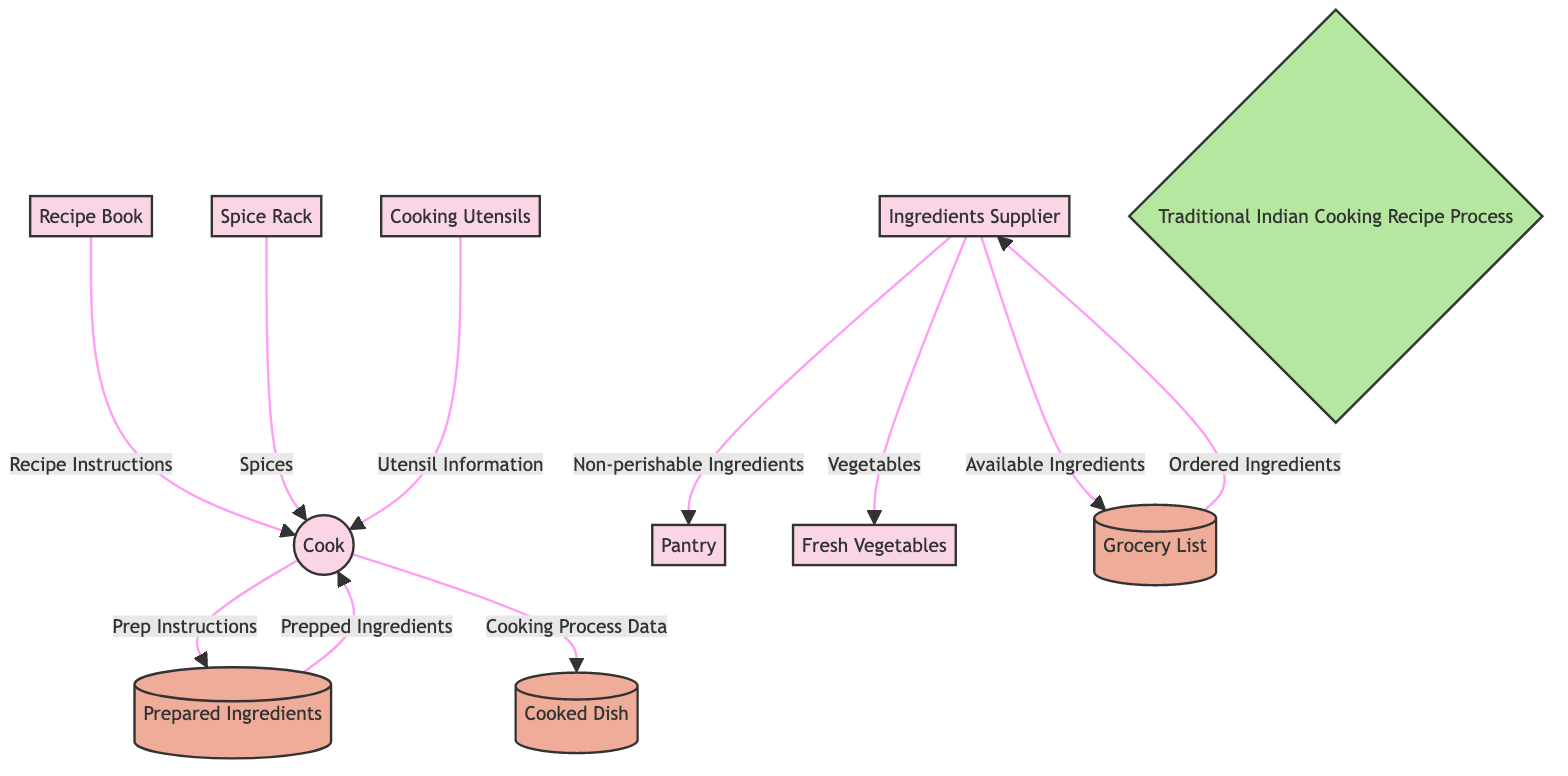What's the total number of entities in the diagram? The diagram lists seven entities: Cook, Recipe Book, Ingredients Supplier, Cooking Utensils, Spice Rack, Pantry, and Fresh Vegetables. Counting these gives a total of seven entities.
Answer: 7 What is the first data flow in the diagram? The first data flow shown in the diagram goes from the Recipe Book to the Cook, providing Recipe Instructions.
Answer: Recipe Instructions How many data stores are present in the diagram? The diagram includes three data stores: Grocery List, Prepared Ingredients, and Cooked Dish. Counting these gives a total of three data stores.
Answer: 3 What does the Cook receive from the Spice Rack? The flow from Spice Rack to Cook indicates that the Cook receives Spices. This is explicitly shown in the diagram.
Answer: Spices What inputs does the Ingredients Supplier provide to the Grocery List? The Ingredients Supplier provides Available Ingredients to the Grocery List. This is indicated by the directed data flow in the diagram.
Answer: Available Ingredients How does the Cook interact with the Prepared Ingredients? The Cook sends Prep Instructions to Prepared Ingredients and receives Prepped Ingredients back from it. This two-way interaction is reflected in the diagram.
Answer: Two-way interaction What are the final outputs of the Cook's process? According to the diagram, the final output of the Cook's process is the Cooked Dish, which is clarified by the flow showing Cooking Process Data being sent to the Cooked Dish.
Answer: Cooked Dish What type of ingredients does the Ingredients Supplier provide to the Pantry? The data flow from Ingredients Supplier to Pantry specifically states Non-perishable Ingredients, indicating the kind of ingredients involved.
Answer: Non-perishable Ingredients How many distinct connections does the Cook have in the diagram? By examining the diagram, the Cook has five distinct connections: one to Prepared Ingredients, one to the Spice Rack, one to Cooking Utensils, one to the Grocery List, and one to Cooked Dish, which sums up to five connections.
Answer: 5 What is the purpose of the Grocery List in this process? The Grocery List acts as a repository for Ordered Ingredients, which is indicated by the data flow from Grocery List back to the Ingredients Supplier.
Answer: Repository for Ordered Ingredients 